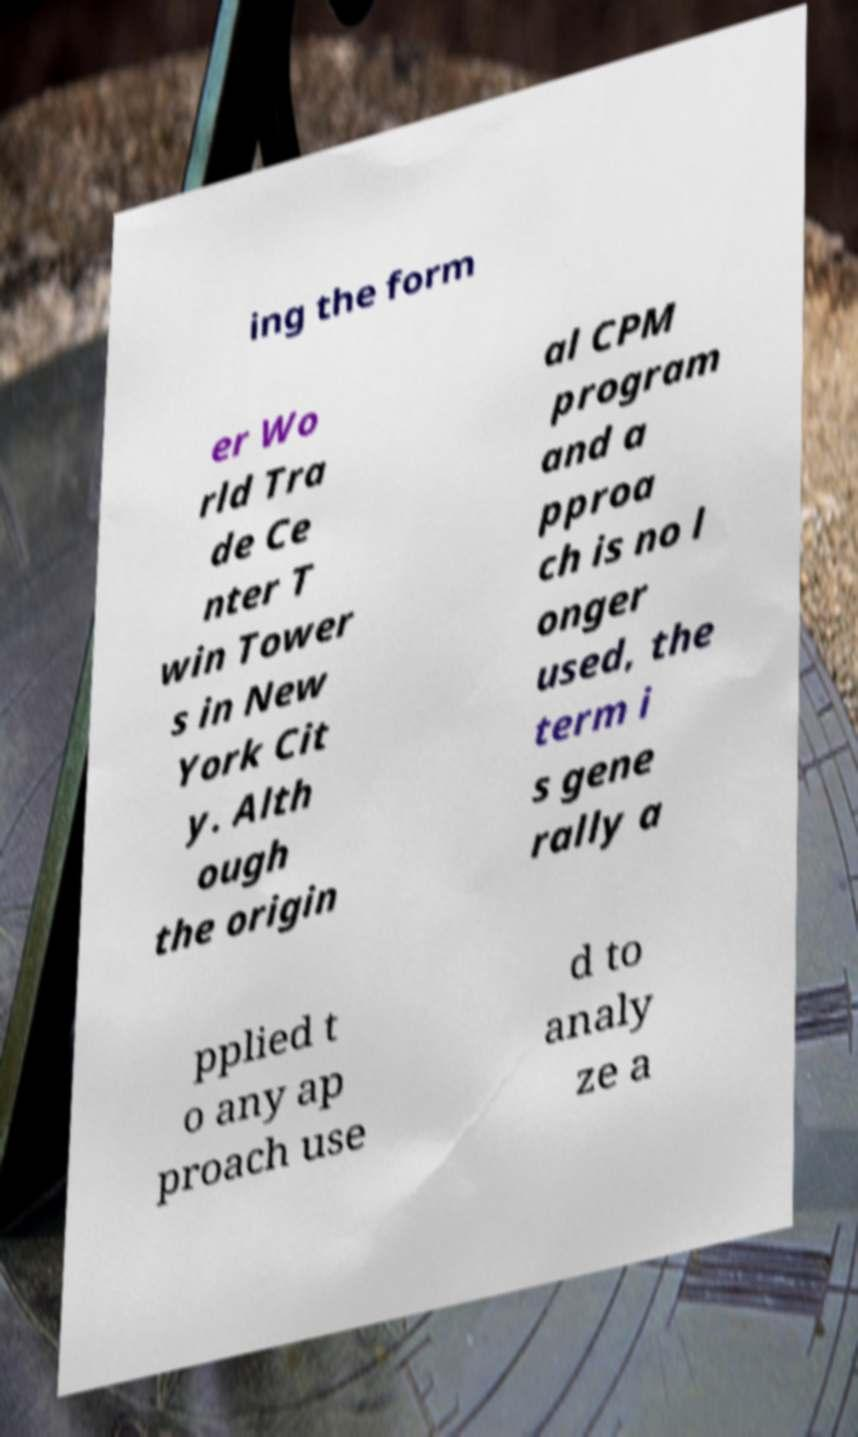Can you accurately transcribe the text from the provided image for me? ing the form er Wo rld Tra de Ce nter T win Tower s in New York Cit y. Alth ough the origin al CPM program and a pproa ch is no l onger used, the term i s gene rally a pplied t o any ap proach use d to analy ze a 